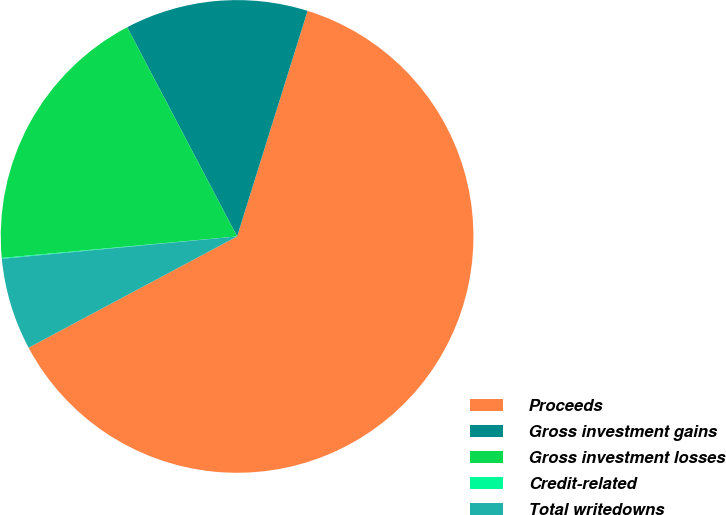Convert chart to OTSL. <chart><loc_0><loc_0><loc_500><loc_500><pie_chart><fcel>Proceeds<fcel>Gross investment gains<fcel>Gross investment losses<fcel>Credit-related<fcel>Total writedowns<nl><fcel>62.38%<fcel>12.52%<fcel>18.75%<fcel>0.06%<fcel>6.29%<nl></chart> 